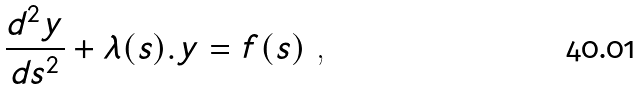Convert formula to latex. <formula><loc_0><loc_0><loc_500><loc_500>\frac { d ^ { 2 } y } { d s ^ { 2 } } + \lambda ( s ) . y = f ( s ) \text { ,}</formula> 